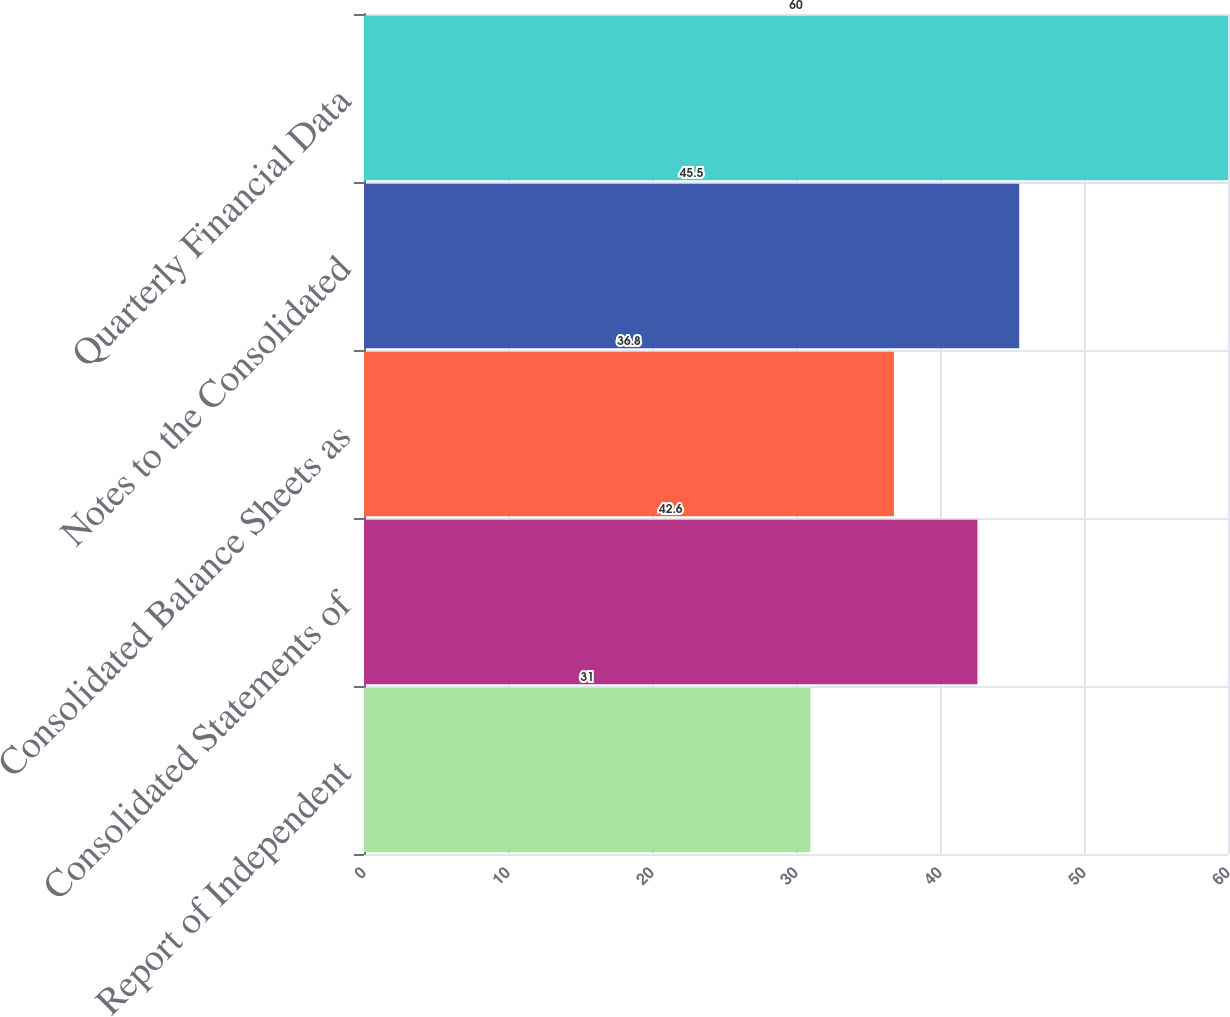Convert chart to OTSL. <chart><loc_0><loc_0><loc_500><loc_500><bar_chart><fcel>Report of Independent<fcel>Consolidated Statements of<fcel>Consolidated Balance Sheets as<fcel>Notes to the Consolidated<fcel>Quarterly Financial Data<nl><fcel>31<fcel>42.6<fcel>36.8<fcel>45.5<fcel>60<nl></chart> 